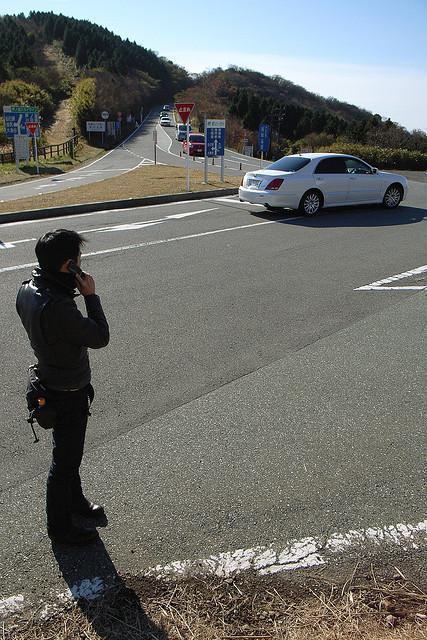What shape is the red sign?
Choose the correct response, then elucidate: 'Answer: answer
Rationale: rationale.'
Options: Rhombus, sphere, triangular, circular. Answer: triangular.
Rationale: The shape is a triangle. 